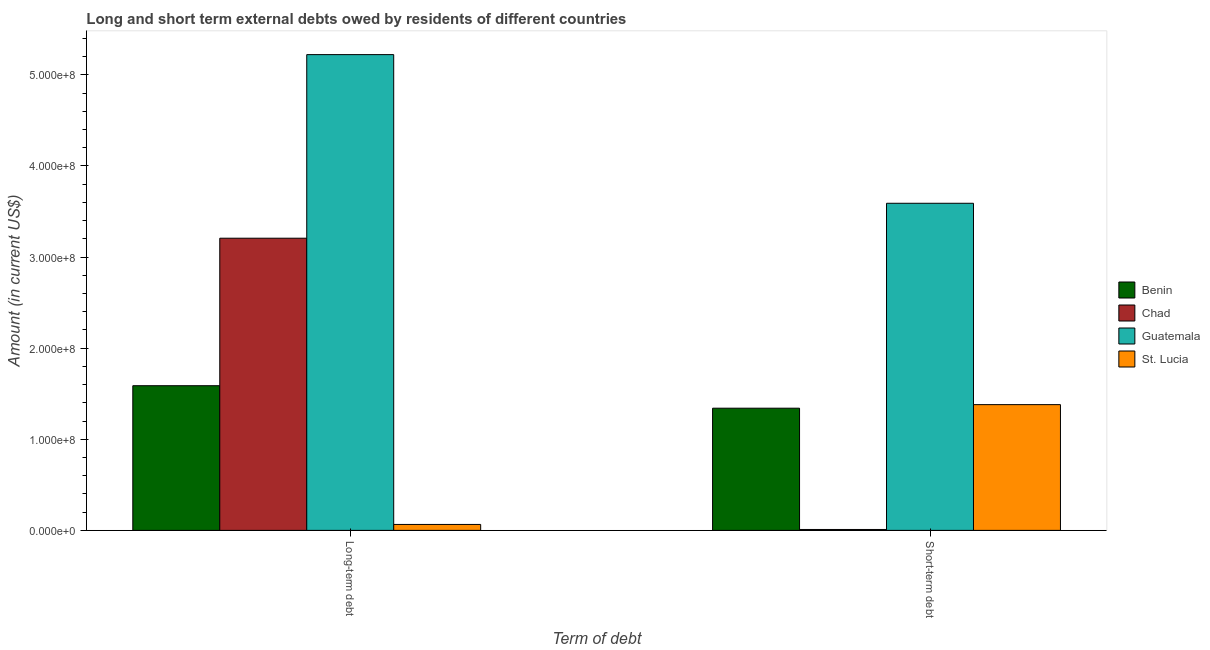How many different coloured bars are there?
Your answer should be very brief. 4. Are the number of bars on each tick of the X-axis equal?
Provide a short and direct response. Yes. How many bars are there on the 2nd tick from the left?
Give a very brief answer. 4. What is the label of the 2nd group of bars from the left?
Offer a very short reply. Short-term debt. What is the short-term debts owed by residents in Guatemala?
Your answer should be compact. 3.59e+08. Across all countries, what is the maximum short-term debts owed by residents?
Provide a succinct answer. 3.59e+08. Across all countries, what is the minimum long-term debts owed by residents?
Keep it short and to the point. 6.51e+06. In which country was the long-term debts owed by residents maximum?
Ensure brevity in your answer.  Guatemala. In which country was the short-term debts owed by residents minimum?
Your answer should be very brief. Chad. What is the total long-term debts owed by residents in the graph?
Your response must be concise. 1.01e+09. What is the difference between the long-term debts owed by residents in Chad and that in Guatemala?
Give a very brief answer. -2.01e+08. What is the difference between the long-term debts owed by residents in Benin and the short-term debts owed by residents in Chad?
Offer a terse response. 1.58e+08. What is the average long-term debts owed by residents per country?
Ensure brevity in your answer.  2.52e+08. What is the difference between the long-term debts owed by residents and short-term debts owed by residents in St. Lucia?
Provide a short and direct response. -1.31e+08. In how many countries, is the short-term debts owed by residents greater than 100000000 US$?
Give a very brief answer. 3. What is the ratio of the long-term debts owed by residents in Chad to that in Guatemala?
Ensure brevity in your answer.  0.61. In how many countries, is the short-term debts owed by residents greater than the average short-term debts owed by residents taken over all countries?
Offer a very short reply. 1. What does the 1st bar from the left in Short-term debt represents?
Ensure brevity in your answer.  Benin. What does the 3rd bar from the right in Short-term debt represents?
Your answer should be very brief. Chad. How many bars are there?
Offer a terse response. 8. Are all the bars in the graph horizontal?
Keep it short and to the point. No. Does the graph contain grids?
Your answer should be compact. No. Where does the legend appear in the graph?
Ensure brevity in your answer.  Center right. How many legend labels are there?
Your response must be concise. 4. What is the title of the graph?
Your response must be concise. Long and short term external debts owed by residents of different countries. What is the label or title of the X-axis?
Your answer should be compact. Term of debt. What is the Amount (in current US$) of Benin in Long-term debt?
Your answer should be compact. 1.59e+08. What is the Amount (in current US$) in Chad in Long-term debt?
Offer a very short reply. 3.21e+08. What is the Amount (in current US$) of Guatemala in Long-term debt?
Your response must be concise. 5.22e+08. What is the Amount (in current US$) of St. Lucia in Long-term debt?
Offer a very short reply. 6.51e+06. What is the Amount (in current US$) in Benin in Short-term debt?
Provide a succinct answer. 1.34e+08. What is the Amount (in current US$) in Guatemala in Short-term debt?
Make the answer very short. 3.59e+08. What is the Amount (in current US$) in St. Lucia in Short-term debt?
Offer a very short reply. 1.38e+08. Across all Term of debt, what is the maximum Amount (in current US$) in Benin?
Offer a very short reply. 1.59e+08. Across all Term of debt, what is the maximum Amount (in current US$) in Chad?
Keep it short and to the point. 3.21e+08. Across all Term of debt, what is the maximum Amount (in current US$) of Guatemala?
Keep it short and to the point. 5.22e+08. Across all Term of debt, what is the maximum Amount (in current US$) of St. Lucia?
Your response must be concise. 1.38e+08. Across all Term of debt, what is the minimum Amount (in current US$) in Benin?
Provide a succinct answer. 1.34e+08. Across all Term of debt, what is the minimum Amount (in current US$) of Guatemala?
Ensure brevity in your answer.  3.59e+08. Across all Term of debt, what is the minimum Amount (in current US$) of St. Lucia?
Your answer should be very brief. 6.51e+06. What is the total Amount (in current US$) in Benin in the graph?
Your answer should be compact. 2.93e+08. What is the total Amount (in current US$) of Chad in the graph?
Your answer should be very brief. 3.22e+08. What is the total Amount (in current US$) of Guatemala in the graph?
Your response must be concise. 8.81e+08. What is the total Amount (in current US$) of St. Lucia in the graph?
Keep it short and to the point. 1.45e+08. What is the difference between the Amount (in current US$) in Benin in Long-term debt and that in Short-term debt?
Your answer should be very brief. 2.47e+07. What is the difference between the Amount (in current US$) of Chad in Long-term debt and that in Short-term debt?
Your answer should be compact. 3.20e+08. What is the difference between the Amount (in current US$) of Guatemala in Long-term debt and that in Short-term debt?
Offer a very short reply. 1.63e+08. What is the difference between the Amount (in current US$) in St. Lucia in Long-term debt and that in Short-term debt?
Give a very brief answer. -1.31e+08. What is the difference between the Amount (in current US$) of Benin in Long-term debt and the Amount (in current US$) of Chad in Short-term debt?
Offer a very short reply. 1.58e+08. What is the difference between the Amount (in current US$) of Benin in Long-term debt and the Amount (in current US$) of Guatemala in Short-term debt?
Your answer should be very brief. -2.00e+08. What is the difference between the Amount (in current US$) in Benin in Long-term debt and the Amount (in current US$) in St. Lucia in Short-term debt?
Offer a very short reply. 2.08e+07. What is the difference between the Amount (in current US$) in Chad in Long-term debt and the Amount (in current US$) in Guatemala in Short-term debt?
Your answer should be very brief. -3.84e+07. What is the difference between the Amount (in current US$) of Chad in Long-term debt and the Amount (in current US$) of St. Lucia in Short-term debt?
Offer a terse response. 1.83e+08. What is the difference between the Amount (in current US$) of Guatemala in Long-term debt and the Amount (in current US$) of St. Lucia in Short-term debt?
Your answer should be compact. 3.84e+08. What is the average Amount (in current US$) of Benin per Term of debt?
Ensure brevity in your answer.  1.46e+08. What is the average Amount (in current US$) of Chad per Term of debt?
Keep it short and to the point. 1.61e+08. What is the average Amount (in current US$) in Guatemala per Term of debt?
Your answer should be very brief. 4.41e+08. What is the average Amount (in current US$) of St. Lucia per Term of debt?
Your answer should be compact. 7.23e+07. What is the difference between the Amount (in current US$) of Benin and Amount (in current US$) of Chad in Long-term debt?
Provide a succinct answer. -1.62e+08. What is the difference between the Amount (in current US$) of Benin and Amount (in current US$) of Guatemala in Long-term debt?
Your answer should be compact. -3.63e+08. What is the difference between the Amount (in current US$) of Benin and Amount (in current US$) of St. Lucia in Long-term debt?
Your answer should be very brief. 1.52e+08. What is the difference between the Amount (in current US$) in Chad and Amount (in current US$) in Guatemala in Long-term debt?
Ensure brevity in your answer.  -2.01e+08. What is the difference between the Amount (in current US$) of Chad and Amount (in current US$) of St. Lucia in Long-term debt?
Offer a terse response. 3.14e+08. What is the difference between the Amount (in current US$) in Guatemala and Amount (in current US$) in St. Lucia in Long-term debt?
Provide a succinct answer. 5.16e+08. What is the difference between the Amount (in current US$) in Benin and Amount (in current US$) in Chad in Short-term debt?
Make the answer very short. 1.33e+08. What is the difference between the Amount (in current US$) of Benin and Amount (in current US$) of Guatemala in Short-term debt?
Your answer should be very brief. -2.25e+08. What is the difference between the Amount (in current US$) in Benin and Amount (in current US$) in St. Lucia in Short-term debt?
Make the answer very short. -3.91e+06. What is the difference between the Amount (in current US$) in Chad and Amount (in current US$) in Guatemala in Short-term debt?
Give a very brief answer. -3.58e+08. What is the difference between the Amount (in current US$) of Chad and Amount (in current US$) of St. Lucia in Short-term debt?
Offer a terse response. -1.37e+08. What is the difference between the Amount (in current US$) in Guatemala and Amount (in current US$) in St. Lucia in Short-term debt?
Your answer should be very brief. 2.21e+08. What is the ratio of the Amount (in current US$) in Benin in Long-term debt to that in Short-term debt?
Your response must be concise. 1.18. What is the ratio of the Amount (in current US$) of Chad in Long-term debt to that in Short-term debt?
Keep it short and to the point. 320.64. What is the ratio of the Amount (in current US$) in Guatemala in Long-term debt to that in Short-term debt?
Keep it short and to the point. 1.45. What is the ratio of the Amount (in current US$) of St. Lucia in Long-term debt to that in Short-term debt?
Your response must be concise. 0.05. What is the difference between the highest and the second highest Amount (in current US$) in Benin?
Ensure brevity in your answer.  2.47e+07. What is the difference between the highest and the second highest Amount (in current US$) of Chad?
Ensure brevity in your answer.  3.20e+08. What is the difference between the highest and the second highest Amount (in current US$) in Guatemala?
Your answer should be compact. 1.63e+08. What is the difference between the highest and the second highest Amount (in current US$) of St. Lucia?
Keep it short and to the point. 1.31e+08. What is the difference between the highest and the lowest Amount (in current US$) in Benin?
Make the answer very short. 2.47e+07. What is the difference between the highest and the lowest Amount (in current US$) of Chad?
Offer a very short reply. 3.20e+08. What is the difference between the highest and the lowest Amount (in current US$) of Guatemala?
Your answer should be compact. 1.63e+08. What is the difference between the highest and the lowest Amount (in current US$) of St. Lucia?
Keep it short and to the point. 1.31e+08. 